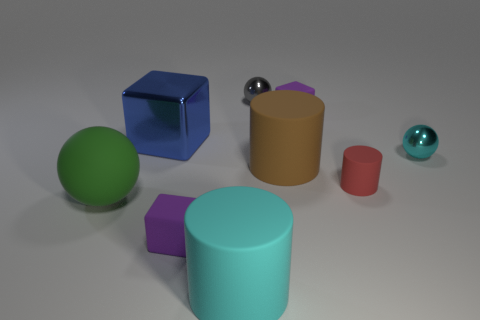Subtract all large matte cylinders. How many cylinders are left? 1 Subtract 2 cylinders. How many cylinders are left? 1 Subtract all blocks. How many objects are left? 6 Subtract all red cylinders. How many purple blocks are left? 2 Subtract all gray balls. How many balls are left? 2 Subtract all red blocks. Subtract all red balls. How many blocks are left? 3 Subtract all gray cylinders. Subtract all tiny purple matte things. How many objects are left? 7 Add 6 tiny balls. How many tiny balls are left? 8 Add 8 tiny purple objects. How many tiny purple objects exist? 10 Subtract 0 blue spheres. How many objects are left? 9 